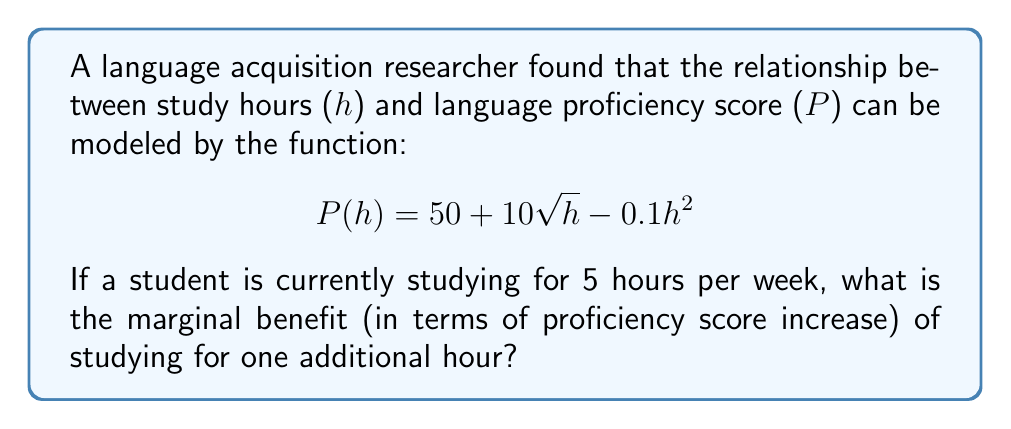Solve this math problem. To find the marginal benefit, we need to calculate the derivative of the function P(h) and evaluate it at h = 5.

1. First, let's find the derivative of P(h):
   $$ P'(h) = \frac{d}{dh}(50 + 10\sqrt{h} - 0.1h^2) $$
   $$ P'(h) = 10 \cdot \frac{1}{2\sqrt{h}} - 0.2h $$
   $$ P'(h) = \frac{5}{\sqrt{h}} - 0.2h $$

2. Now, we evaluate P'(h) at h = 5:
   $$ P'(5) = \frac{5}{\sqrt{5}} - 0.2(5) $$
   $$ P'(5) = \frac{5}{\sqrt{5}} - 1 $$
   $$ P'(5) = \frac{5}{\sqrt{5}} - \frac{\sqrt{5}}{\sqrt{5}} $$
   $$ P'(5) = \frac{5 - \sqrt{5}}{\sqrt{5}} $$

3. Simplify:
   $$ P'(5) = \frac{5 - \sqrt{5}}{\sqrt{5}} \approx 1.2361 $$

The marginal benefit is the rate of change in the proficiency score with respect to study hours, evaluated at the current study time (5 hours). This value represents the increase in proficiency score for one additional hour of study.
Answer: $\frac{5 - \sqrt{5}}{\sqrt{5}}$ (or approximately 1.2361) points 